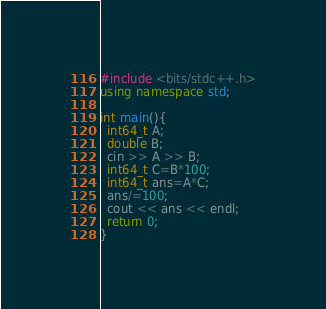Convert code to text. <code><loc_0><loc_0><loc_500><loc_500><_C++_>#include <bits/stdc++.h>
using namespace std;

int main(){
  int64_t A;
  double B;
  cin >> A >> B;
  int64_t C=B*100;
  int64_t ans=A*C;
  ans/=100;
  cout << ans << endl;
  return 0;
}
</code> 